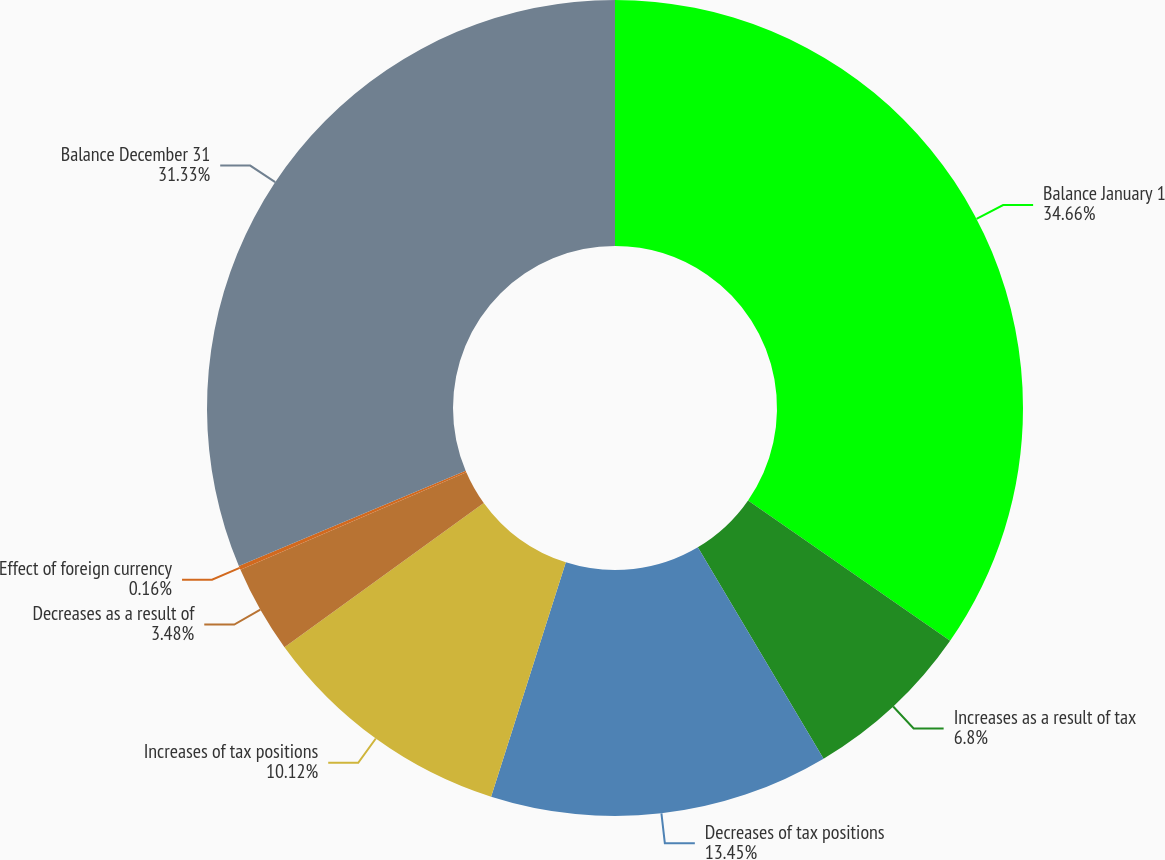<chart> <loc_0><loc_0><loc_500><loc_500><pie_chart><fcel>Balance January 1<fcel>Increases as a result of tax<fcel>Decreases of tax positions<fcel>Increases of tax positions<fcel>Decreases as a result of<fcel>Effect of foreign currency<fcel>Balance December 31<nl><fcel>34.66%<fcel>6.8%<fcel>13.45%<fcel>10.12%<fcel>3.48%<fcel>0.16%<fcel>31.33%<nl></chart> 